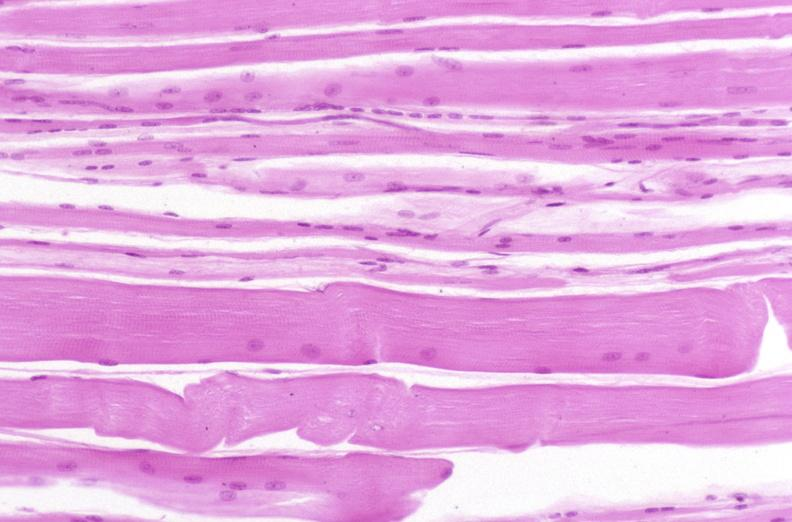what does this image show?
Answer the question using a single word or phrase. Skeletal muscle 